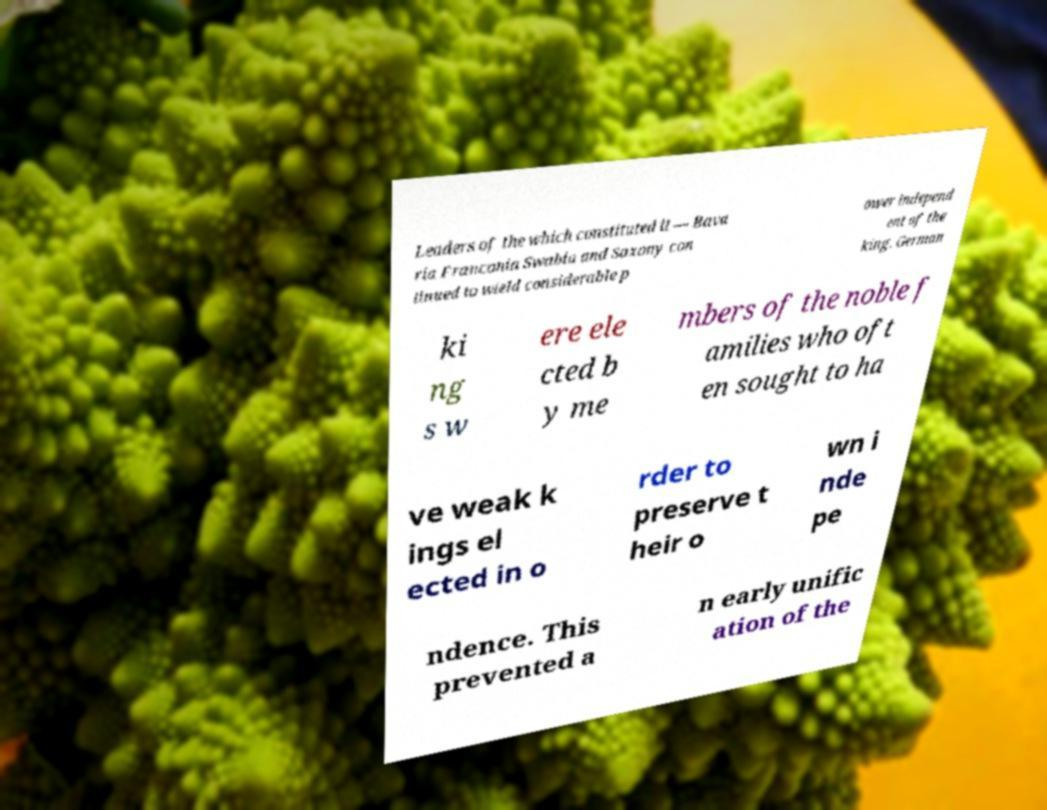Can you read and provide the text displayed in the image?This photo seems to have some interesting text. Can you extract and type it out for me? Leaders of the which constituted it — Bava ria Franconia Swabia and Saxony con tinued to wield considerable p ower independ ent of the king. German ki ng s w ere ele cted b y me mbers of the noble f amilies who oft en sought to ha ve weak k ings el ected in o rder to preserve t heir o wn i nde pe ndence. This prevented a n early unific ation of the 